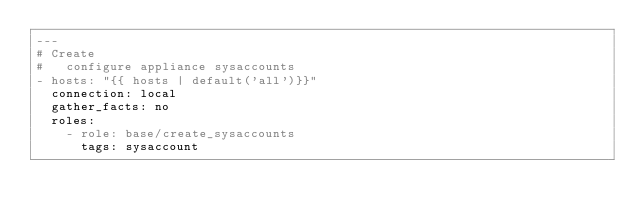Convert code to text. <code><loc_0><loc_0><loc_500><loc_500><_YAML_>---
# Create
#   configure appliance sysaccounts
- hosts: "{{ hosts | default('all')}}"
  connection: local
  gather_facts: no
  roles:
    - role: base/create_sysaccounts
      tags: sysaccount
      </code> 